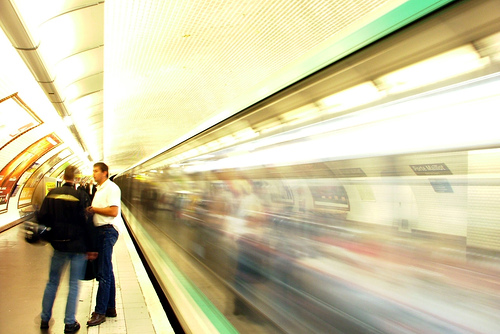Can you guess the time of day this photo was taken? It's challenging to determine the exact time of day from this image due to the controlled lighting conditions inside the subway station. However, the photo seems to lack the rush of commuters that could be indicative of peak hours, suggesting that it might have been taken either before the morning rush or between the peak commuting times.  Are there any indications of the location or the city where this subway is situated? Without specific signage, symbols, or architectural designs that are unique to a particular subway system, it is difficult to ascertain the exact location or city depicted in the image. The photo does not provide enough distinct details to make a precise determination. 